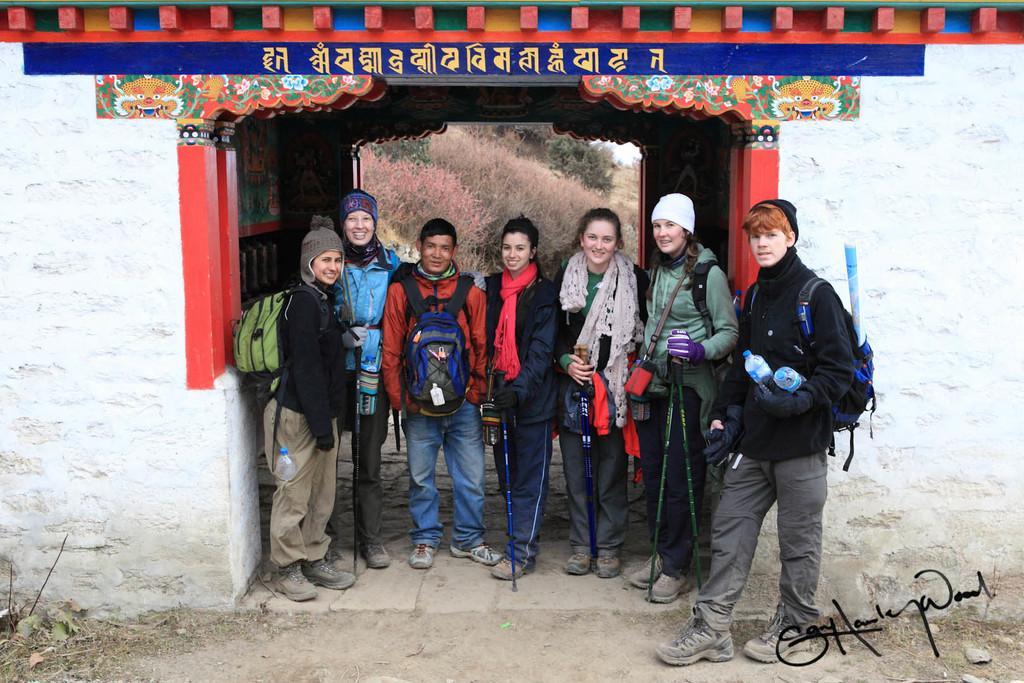Please provide a concise description of this image. In this image there are group of people standing, and some of them are wearing bags and hats. And some of them are holding sticks and bottles, at the bottom there is walkway and some grass. And in the center there is a building, and at the top of the image there is text and in the background there are some trees. And in the bottom right hand corner there is some text. 